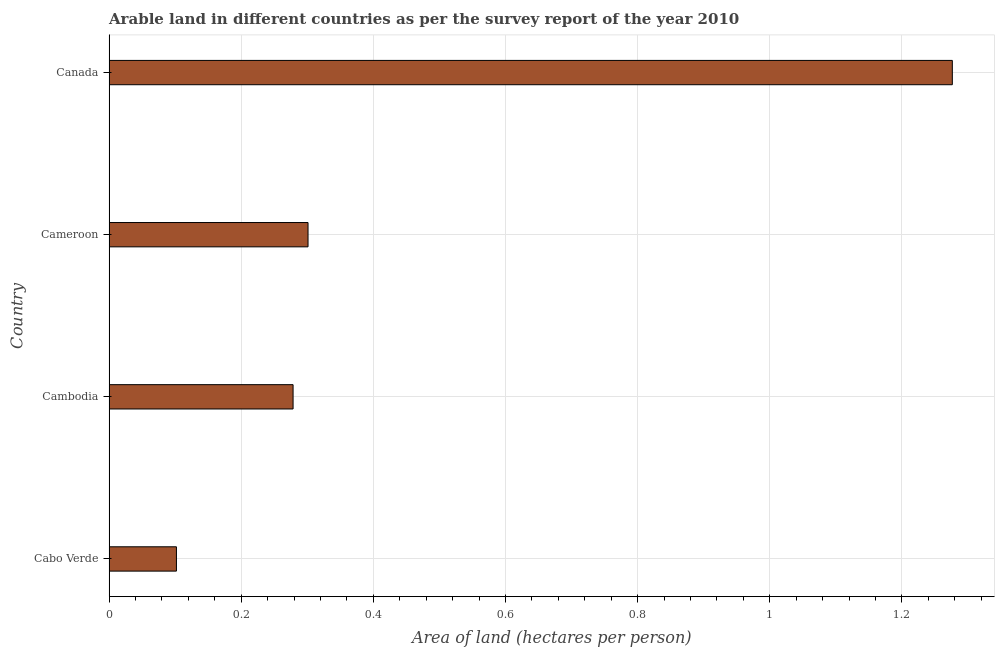Does the graph contain grids?
Your response must be concise. Yes. What is the title of the graph?
Your answer should be compact. Arable land in different countries as per the survey report of the year 2010. What is the label or title of the X-axis?
Offer a very short reply. Area of land (hectares per person). What is the label or title of the Y-axis?
Ensure brevity in your answer.  Country. What is the area of arable land in Canada?
Give a very brief answer. 1.28. Across all countries, what is the maximum area of arable land?
Your answer should be very brief. 1.28. Across all countries, what is the minimum area of arable land?
Offer a terse response. 0.1. In which country was the area of arable land minimum?
Ensure brevity in your answer.  Cabo Verde. What is the sum of the area of arable land?
Provide a short and direct response. 1.96. What is the difference between the area of arable land in Cambodia and Canada?
Keep it short and to the point. -1. What is the average area of arable land per country?
Offer a very short reply. 0.49. What is the median area of arable land?
Provide a short and direct response. 0.29. What is the ratio of the area of arable land in Cabo Verde to that in Cambodia?
Give a very brief answer. 0.37. Is the area of arable land in Cambodia less than that in Cameroon?
Provide a short and direct response. Yes. Is the difference between the area of arable land in Cabo Verde and Cameroon greater than the difference between any two countries?
Provide a succinct answer. No. Is the sum of the area of arable land in Cambodia and Canada greater than the maximum area of arable land across all countries?
Provide a short and direct response. Yes. What is the difference between the highest and the lowest area of arable land?
Ensure brevity in your answer.  1.17. In how many countries, is the area of arable land greater than the average area of arable land taken over all countries?
Provide a succinct answer. 1. How many countries are there in the graph?
Offer a very short reply. 4. What is the difference between two consecutive major ticks on the X-axis?
Make the answer very short. 0.2. Are the values on the major ticks of X-axis written in scientific E-notation?
Your answer should be very brief. No. What is the Area of land (hectares per person) of Cabo Verde?
Provide a short and direct response. 0.1. What is the Area of land (hectares per person) of Cambodia?
Your answer should be very brief. 0.28. What is the Area of land (hectares per person) in Cameroon?
Your response must be concise. 0.3. What is the Area of land (hectares per person) in Canada?
Your answer should be compact. 1.28. What is the difference between the Area of land (hectares per person) in Cabo Verde and Cambodia?
Make the answer very short. -0.18. What is the difference between the Area of land (hectares per person) in Cabo Verde and Cameroon?
Keep it short and to the point. -0.2. What is the difference between the Area of land (hectares per person) in Cabo Verde and Canada?
Keep it short and to the point. -1.17. What is the difference between the Area of land (hectares per person) in Cambodia and Cameroon?
Offer a very short reply. -0.02. What is the difference between the Area of land (hectares per person) in Cambodia and Canada?
Give a very brief answer. -1. What is the difference between the Area of land (hectares per person) in Cameroon and Canada?
Make the answer very short. -0.98. What is the ratio of the Area of land (hectares per person) in Cabo Verde to that in Cambodia?
Ensure brevity in your answer.  0.37. What is the ratio of the Area of land (hectares per person) in Cabo Verde to that in Cameroon?
Your response must be concise. 0.34. What is the ratio of the Area of land (hectares per person) in Cambodia to that in Cameroon?
Ensure brevity in your answer.  0.93. What is the ratio of the Area of land (hectares per person) in Cambodia to that in Canada?
Keep it short and to the point. 0.22. What is the ratio of the Area of land (hectares per person) in Cameroon to that in Canada?
Your answer should be very brief. 0.24. 